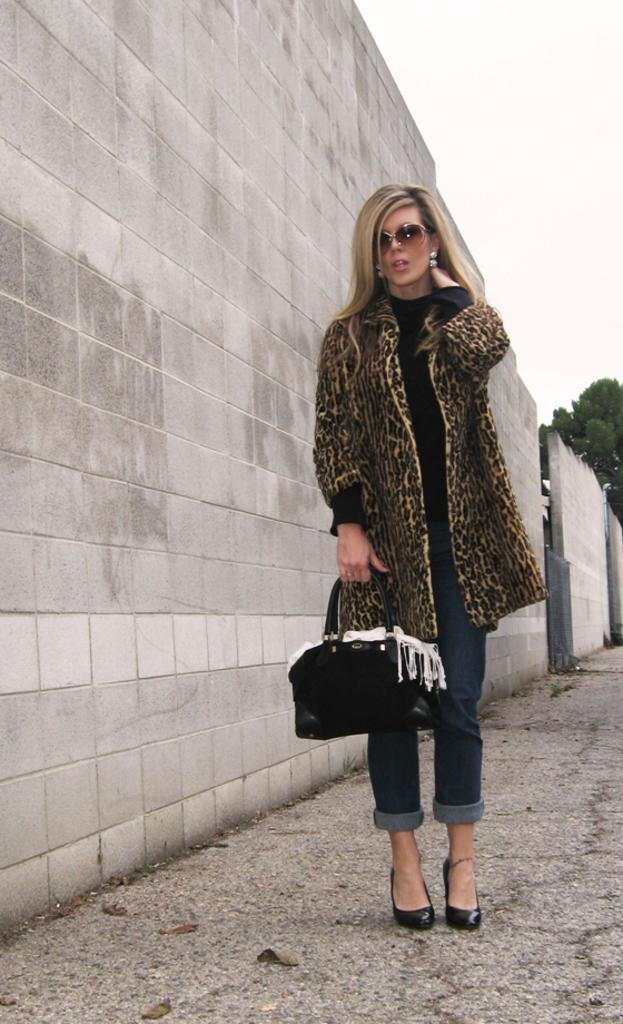Could you give a brief overview of what you see in this image? In the middle of the image a woman is standing and holding a bag. Beside her there is a wall. Top right side of the image there is a sky and tree. 